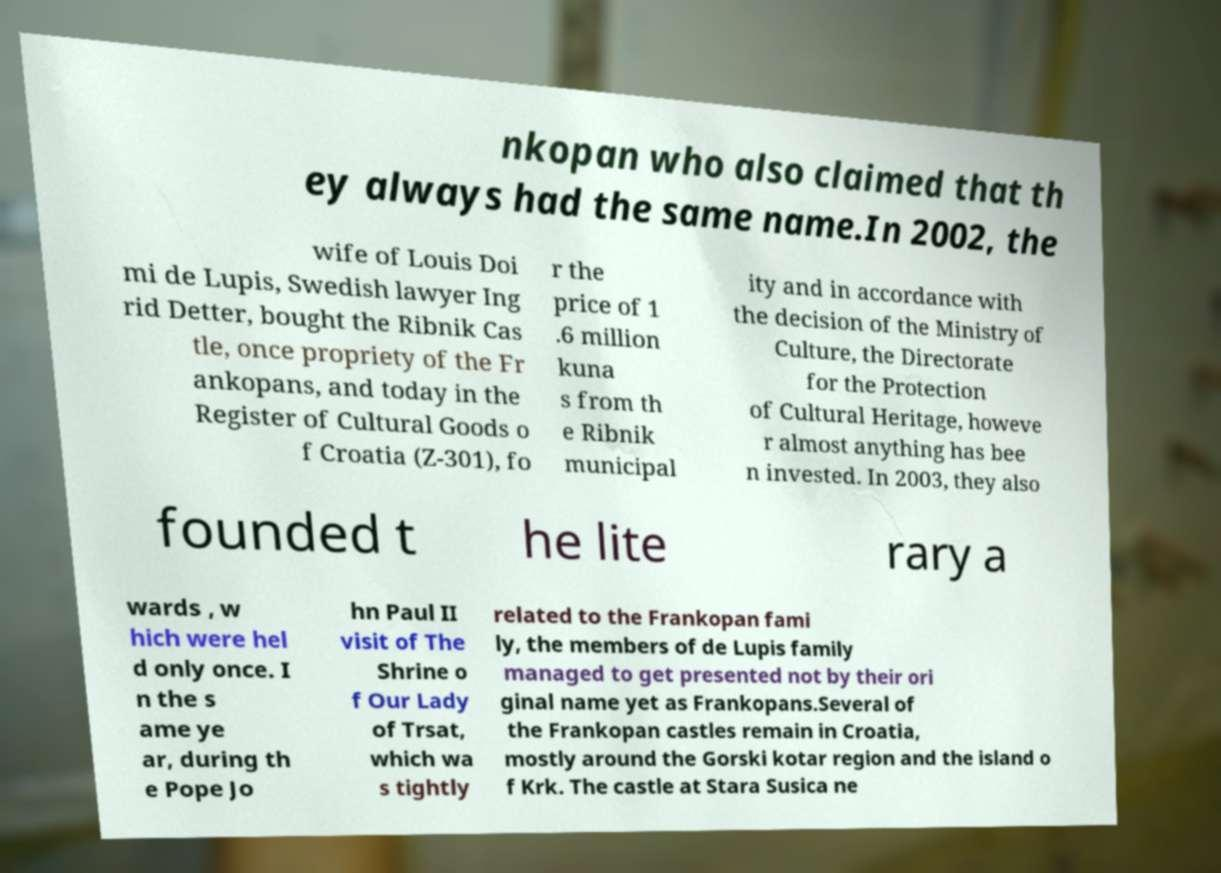Could you assist in decoding the text presented in this image and type it out clearly? nkopan who also claimed that th ey always had the same name.In 2002, the wife of Louis Doi mi de Lupis, Swedish lawyer Ing rid Detter, bought the Ribnik Cas tle, once propriety of the Fr ankopans, and today in the Register of Cultural Goods o f Croatia (Z-301), fo r the price of 1 .6 million kuna s from th e Ribnik municipal ity and in accordance with the decision of the Ministry of Culture, the Directorate for the Protection of Cultural Heritage, howeve r almost anything has bee n invested. In 2003, they also founded t he lite rary a wards , w hich were hel d only once. I n the s ame ye ar, during th e Pope Jo hn Paul II visit of The Shrine o f Our Lady of Trsat, which wa s tightly related to the Frankopan fami ly, the members of de Lupis family managed to get presented not by their ori ginal name yet as Frankopans.Several of the Frankopan castles remain in Croatia, mostly around the Gorski kotar region and the island o f Krk. The castle at Stara Susica ne 